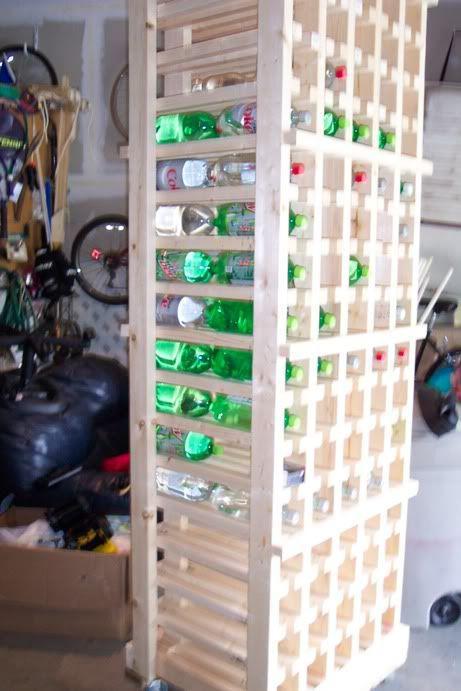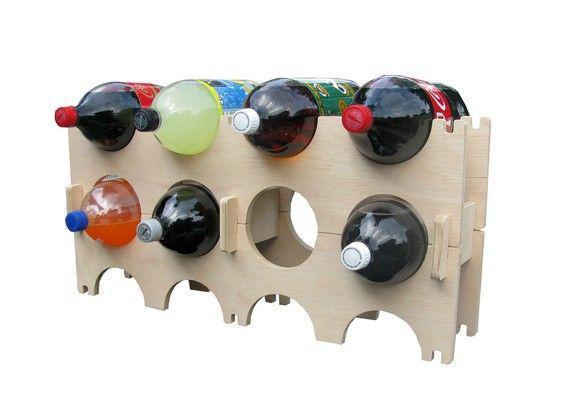The first image is the image on the left, the second image is the image on the right. Evaluate the accuracy of this statement regarding the images: "In one of the images, a single red cola bottle sits on the second highest shelf of a shelf stack with 4 shelves on it.". Is it true? Answer yes or no. No. The first image is the image on the left, the second image is the image on the right. Given the left and right images, does the statement "There are exactly five bottles of soda." hold true? Answer yes or no. No. 